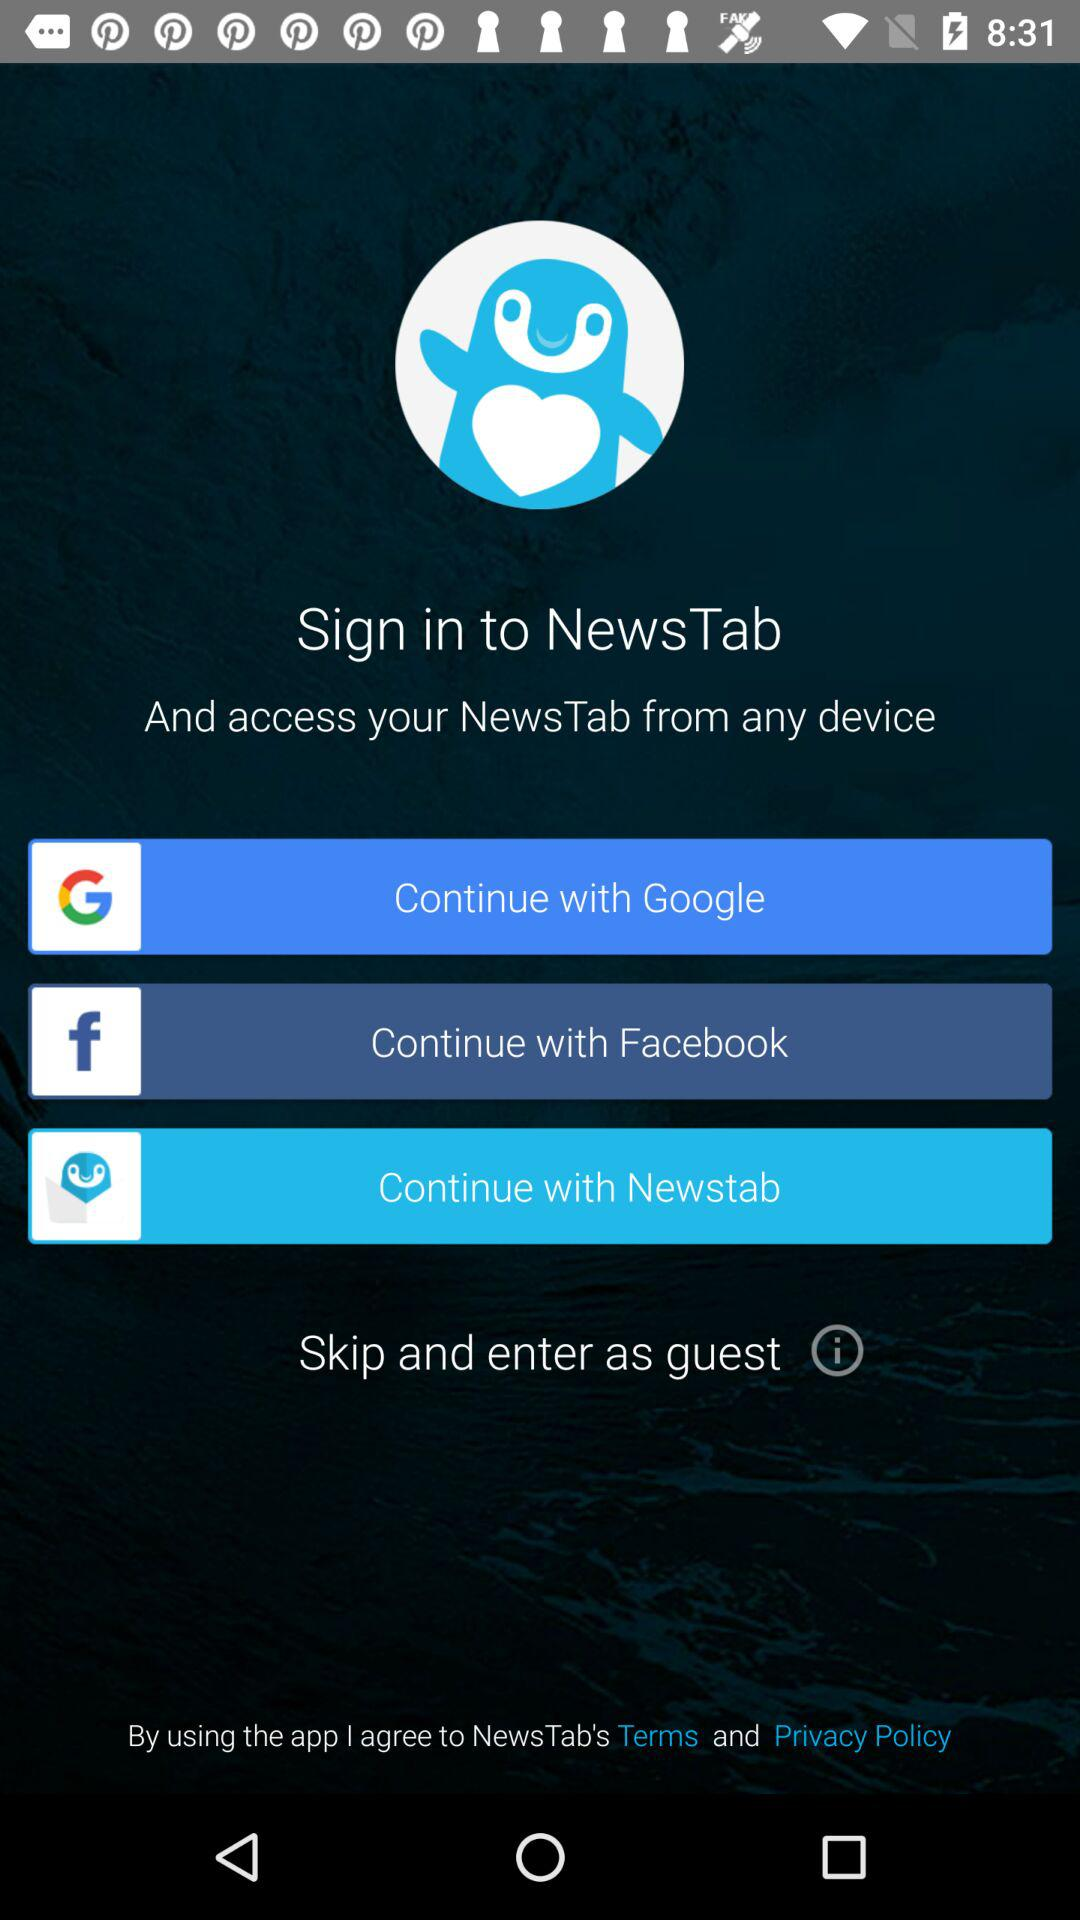How many social media login options are available?
Answer the question using a single word or phrase. 3 